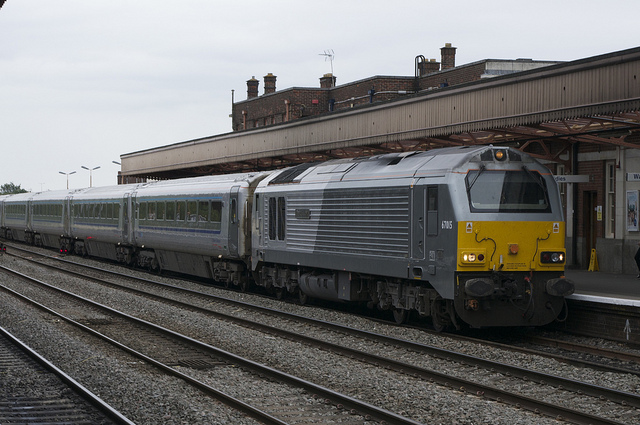Can you tell what time of day or what the weather is like based on this image? Although pinpointing the exact time of day is challenging without a clear view of the sky, the lighting suggests it could be daytime with overcast weather, given the lack of harsh shadows and the muted natural light. The overall tone of the sky and lighting does not suggest direct sunlight. 